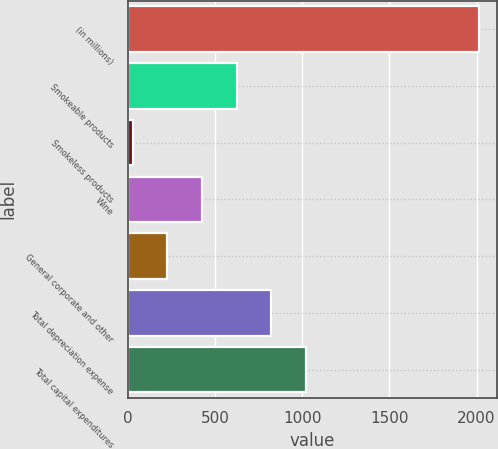<chart> <loc_0><loc_0><loc_500><loc_500><bar_chart><fcel>(in millions)<fcel>Smokeable products<fcel>Smokeless products<fcel>Wine<fcel>General corporate and other<fcel>Total depreciation expense<fcel>Total capital expenditures<nl><fcel>2015<fcel>623.4<fcel>27<fcel>424.6<fcel>225.8<fcel>822.2<fcel>1021<nl></chart> 